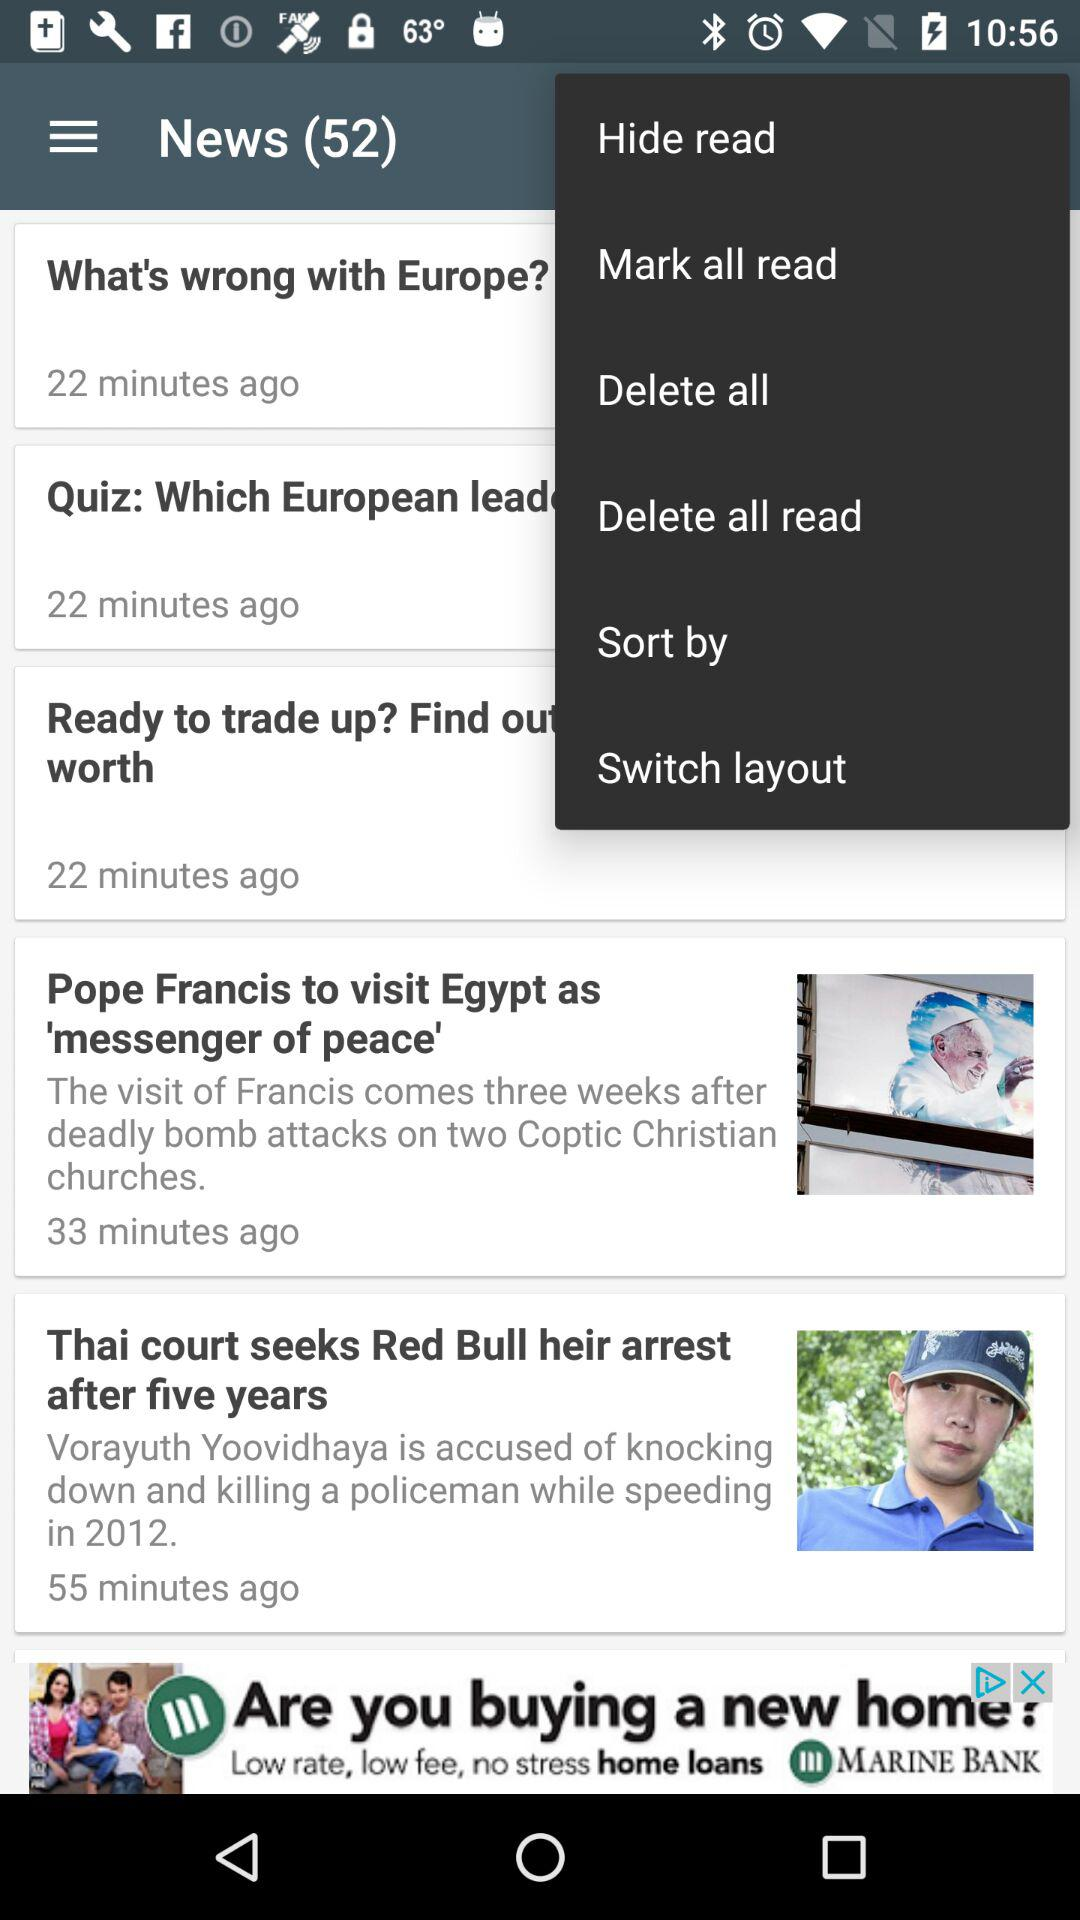How many news articles are there? There are 52 news articles. 